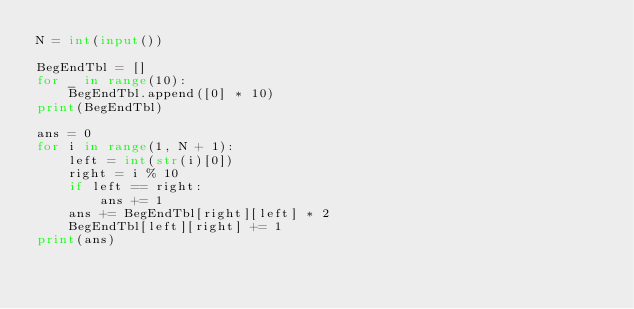<code> <loc_0><loc_0><loc_500><loc_500><_Python_>N = int(input())

BegEndTbl = []
for _ in range(10):
    BegEndTbl.append([0] * 10)
print(BegEndTbl)

ans = 0
for i in range(1, N + 1):
    left = int(str(i)[0])
    right = i % 10
    if left == right:
        ans += 1
    ans += BegEndTbl[right][left] * 2
    BegEndTbl[left][right] += 1
print(ans)</code> 